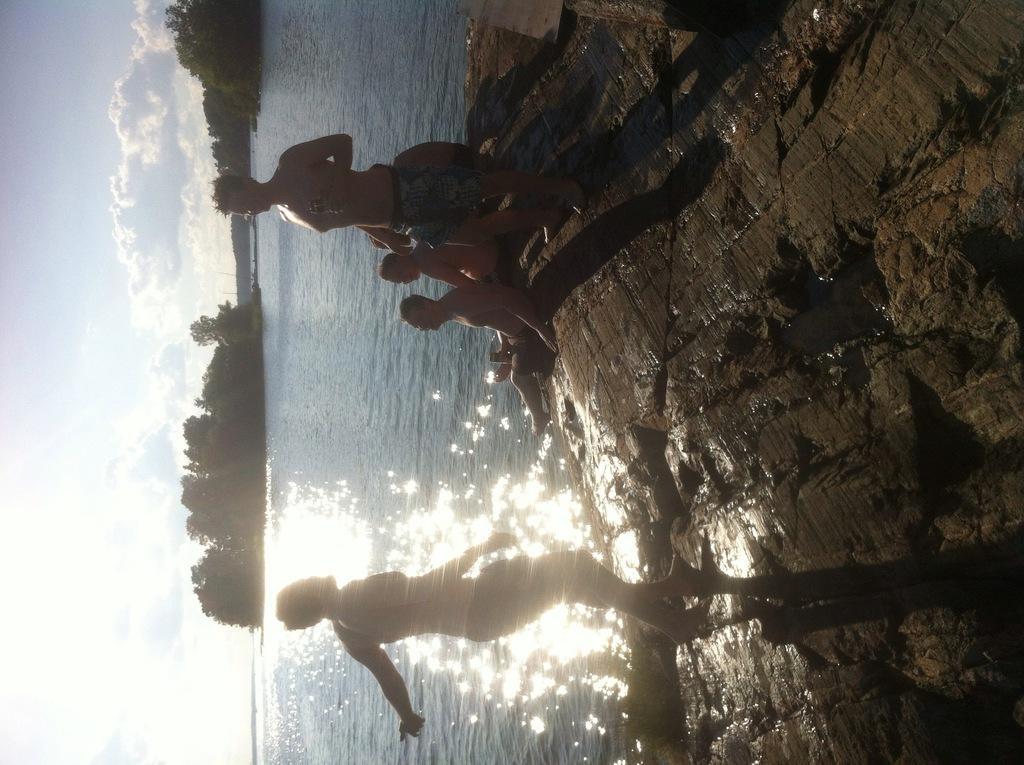Describe this image in one or two sentences. In this image I can see few persons standing and few persons sitting on the ground. In the background I can see the water, few trees and the sky. 